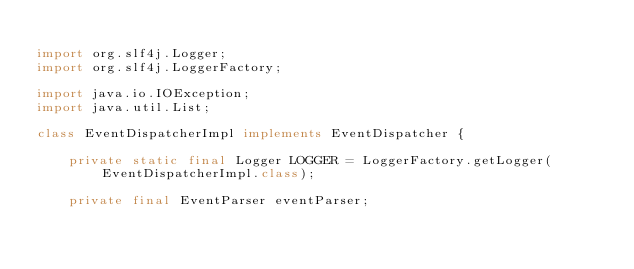Convert code to text. <code><loc_0><loc_0><loc_500><loc_500><_Java_>
import org.slf4j.Logger;
import org.slf4j.LoggerFactory;

import java.io.IOException;
import java.util.List;

class EventDispatcherImpl implements EventDispatcher {

    private static final Logger LOGGER = LoggerFactory.getLogger(EventDispatcherImpl.class);

    private final EventParser eventParser;</code> 